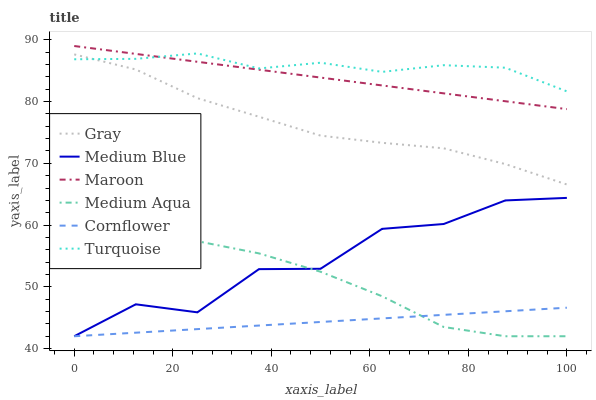Does Turquoise have the minimum area under the curve?
Answer yes or no. No. Does Cornflower have the maximum area under the curve?
Answer yes or no. No. Is Turquoise the smoothest?
Answer yes or no. No. Is Turquoise the roughest?
Answer yes or no. No. Does Turquoise have the lowest value?
Answer yes or no. No. Does Turquoise have the highest value?
Answer yes or no. No. Is Medium Blue less than Turquoise?
Answer yes or no. Yes. Is Gray greater than Medium Blue?
Answer yes or no. Yes. Does Medium Blue intersect Turquoise?
Answer yes or no. No. 